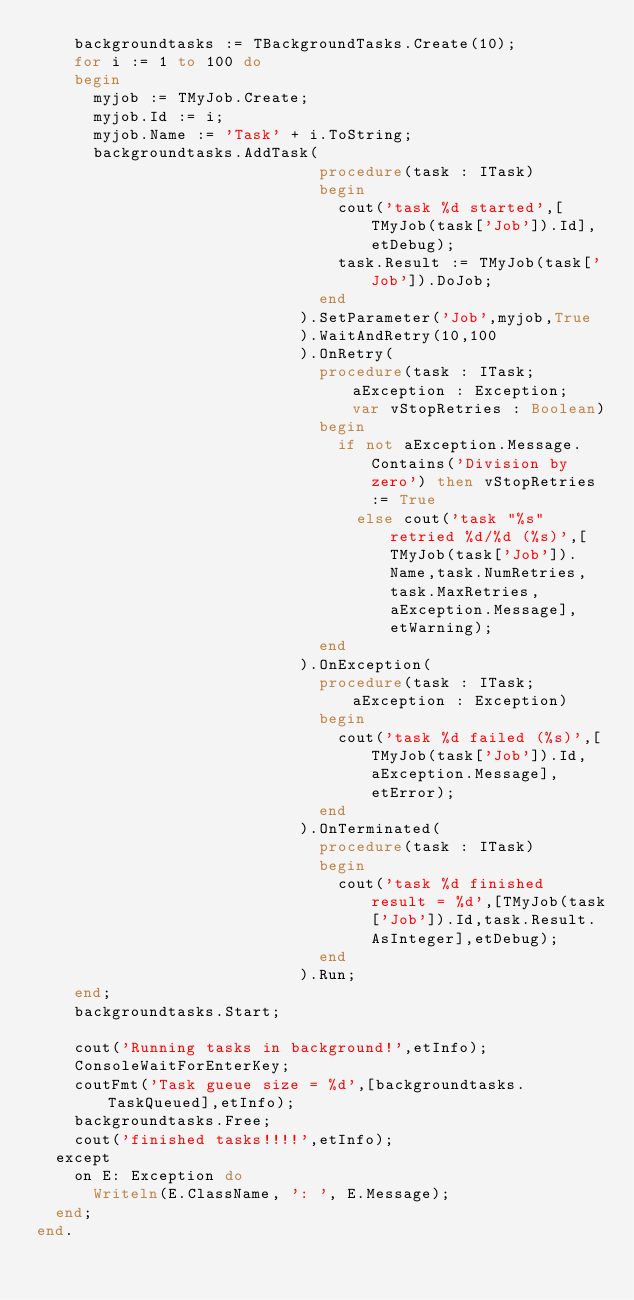<code> <loc_0><loc_0><loc_500><loc_500><_Pascal_>    backgroundtasks := TBackgroundTasks.Create(10);
    for i := 1 to 100 do
    begin
      myjob := TMyJob.Create;
      myjob.Id := i;
      myjob.Name := 'Task' + i.ToString;
      backgroundtasks.AddTask(
                              procedure(task : ITask)
                              begin
                                cout('task %d started',[TMyJob(task['Job']).Id],etDebug);
                                task.Result := TMyJob(task['Job']).DoJob;
                              end
                            ).SetParameter('Job',myjob,True
                            ).WaitAndRetry(10,100
                            ).OnRetry(
                              procedure(task : ITask; aException : Exception;  var vStopRetries : Boolean)
                              begin
                                if not aException.Message.Contains('Division by zero') then vStopRetries := True
                                  else cout('task "%s" retried %d/%d (%s)',[TMyJob(task['Job']).Name,task.NumRetries,task.MaxRetries,aException.Message],etWarning);
                              end
                            ).OnException(
                              procedure(task : ITask; aException : Exception)
                              begin
                                cout('task %d failed (%s)',[TMyJob(task['Job']).Id,aException.Message],etError);
                              end
                            ).OnTerminated(
                              procedure(task : ITask)
                              begin
                                cout('task %d finished result = %d',[TMyJob(task['Job']).Id,task.Result.AsInteger],etDebug);
                              end
                            ).Run;
    end;
    backgroundtasks.Start;

    cout('Running tasks in background!',etInfo);
    ConsoleWaitForEnterKey;
    coutFmt('Task gueue size = %d',[backgroundtasks.TaskQueued],etInfo);
    backgroundtasks.Free;
    cout('finished tasks!!!!',etInfo);
  except
    on E: Exception do
      Writeln(E.ClassName, ': ', E.Message);
  end;
end.
</code> 